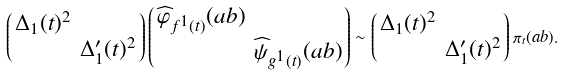Convert formula to latex. <formula><loc_0><loc_0><loc_500><loc_500>\left ( \begin{smallmatrix} \Delta _ { 1 } ( t ) ^ { 2 } & \\ & \Delta ^ { \prime } _ { 1 } ( t ) ^ { 2 } \end{smallmatrix} \right ) \left ( \begin{smallmatrix} \widehat { \varphi } _ { f ^ { 1 } ( t ) } ( a b ) & \\ & \widehat { \psi } _ { g ^ { 1 } ( t ) } ( a b ) \end{smallmatrix} \right ) \sim \left ( \begin{smallmatrix} \Delta _ { 1 } ( t ) ^ { 2 } & \\ & \Delta ^ { \prime } _ { 1 } ( t ) ^ { 2 } \end{smallmatrix} \right ) \pi _ { t } ( a b ) .</formula> 